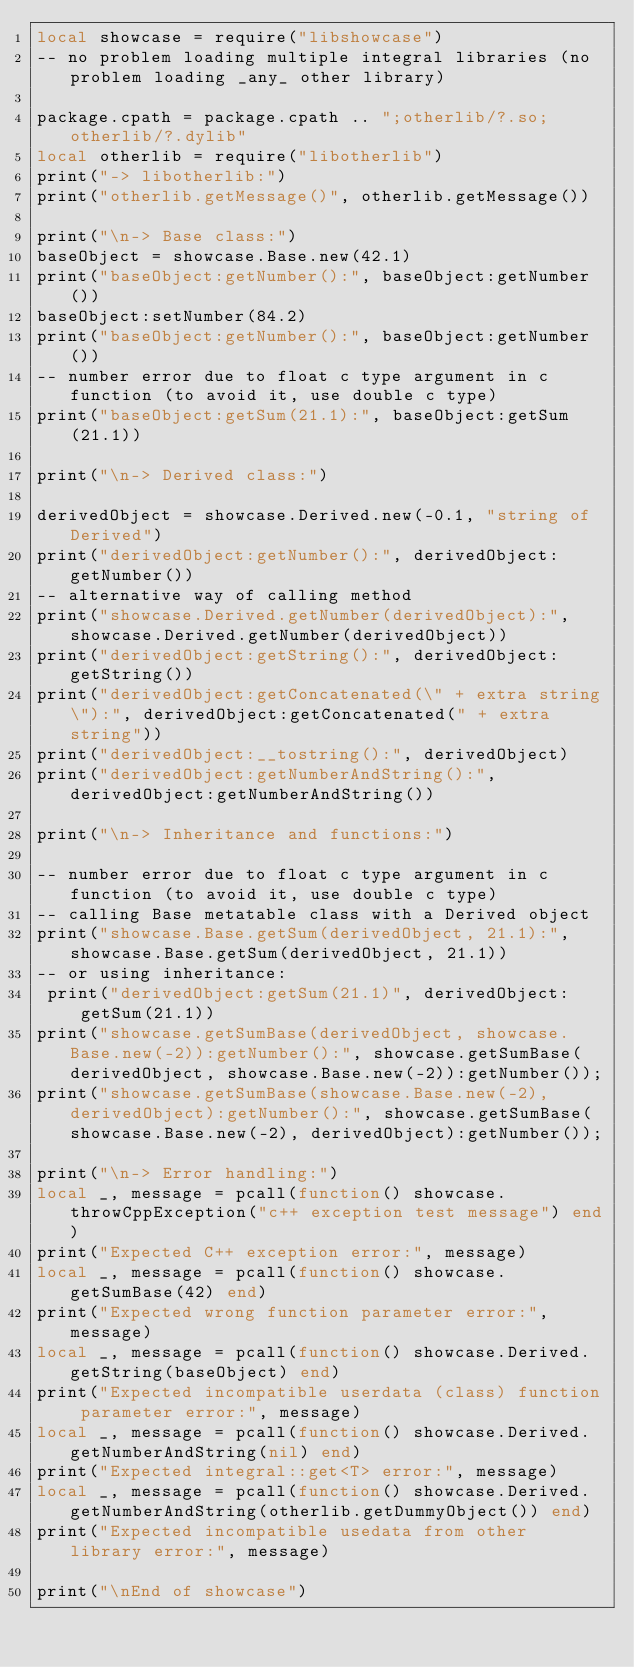<code> <loc_0><loc_0><loc_500><loc_500><_Lua_>local showcase = require("libshowcase")
-- no problem loading multiple integral libraries (no problem loading _any_ other library)

package.cpath = package.cpath .. ";otherlib/?.so;otherlib/?.dylib"
local otherlib = require("libotherlib")
print("-> libotherlib:")
print("otherlib.getMessage()", otherlib.getMessage())

print("\n-> Base class:")
baseObject = showcase.Base.new(42.1)
print("baseObject:getNumber():", baseObject:getNumber())
baseObject:setNumber(84.2)
print("baseObject:getNumber():", baseObject:getNumber())
-- number error due to float c type argument in c function (to avoid it, use double c type)
print("baseObject:getSum(21.1):", baseObject:getSum(21.1))

print("\n-> Derived class:")

derivedObject = showcase.Derived.new(-0.1, "string of Derived")
print("derivedObject:getNumber():", derivedObject:getNumber())
-- alternative way of calling method
print("showcase.Derived.getNumber(derivedObject):", showcase.Derived.getNumber(derivedObject))
print("derivedObject:getString():", derivedObject:getString())
print("derivedObject:getConcatenated(\" + extra string\"):", derivedObject:getConcatenated(" + extra string"))
print("derivedObject:__tostring():", derivedObject)
print("derivedObject:getNumberAndString():", derivedObject:getNumberAndString())

print("\n-> Inheritance and functions:")

-- number error due to float c type argument in c function (to avoid it, use double c type)
-- calling Base metatable class with a Derived object
print("showcase.Base.getSum(derivedObject, 21.1):", showcase.Base.getSum(derivedObject, 21.1))
-- or using inheritance:
 print("derivedObject:getSum(21.1)", derivedObject:getSum(21.1))
print("showcase.getSumBase(derivedObject, showcase.Base.new(-2)):getNumber():", showcase.getSumBase(derivedObject, showcase.Base.new(-2)):getNumber());
print("showcase.getSumBase(showcase.Base.new(-2), derivedObject):getNumber():", showcase.getSumBase(showcase.Base.new(-2), derivedObject):getNumber());

print("\n-> Error handling:")
local _, message = pcall(function() showcase.throwCppException("c++ exception test message") end)
print("Expected C++ exception error:", message)
local _, message = pcall(function() showcase.getSumBase(42) end)
print("Expected wrong function parameter error:", message)
local _, message = pcall(function() showcase.Derived.getString(baseObject) end)
print("Expected incompatible userdata (class) function parameter error:", message)
local _, message = pcall(function() showcase.Derived.getNumberAndString(nil) end)
print("Expected integral::get<T> error:", message)
local _, message = pcall(function() showcase.Derived.getNumberAndString(otherlib.getDummyObject()) end)
print("Expected incompatible usedata from other library error:", message)

print("\nEnd of showcase")
</code> 